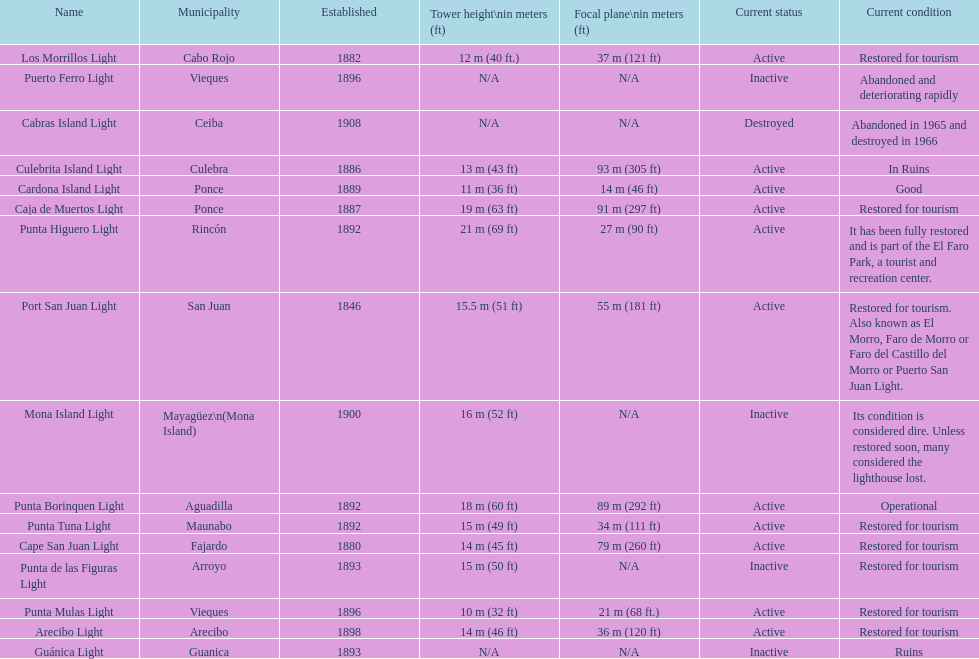How many towers are at least 18 meters tall? 3. 